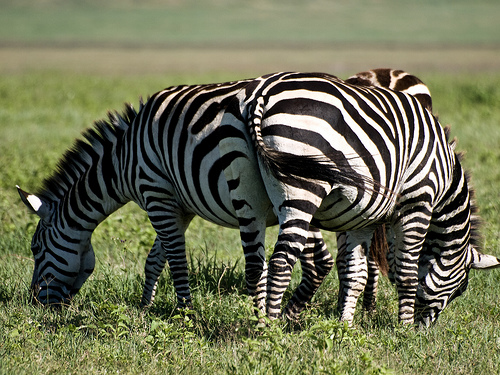Are these zebras a part of a larger herd, or are they isolated? While only a few zebras are visible in the photograph, they are naturally social creatures that usually form larger herds. It's probable that more members of their group are nearby, out of the frame. 